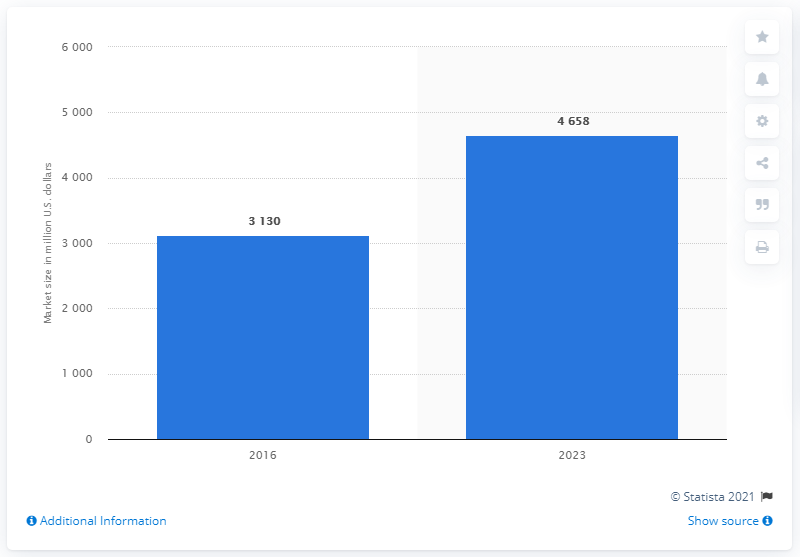Point out several critical features in this image. In 2023, the value was higher than in 2016 by 1528. The year 2023 is depicted in this representation. The global orthopedic orthotics market reached a value of 3130 million dollars in 2016. The market is expected to grow significantly by 2023, with an estimate of 4,658%. The forecast for the global orthopedic orthotics market in 2023 is predicted to be 